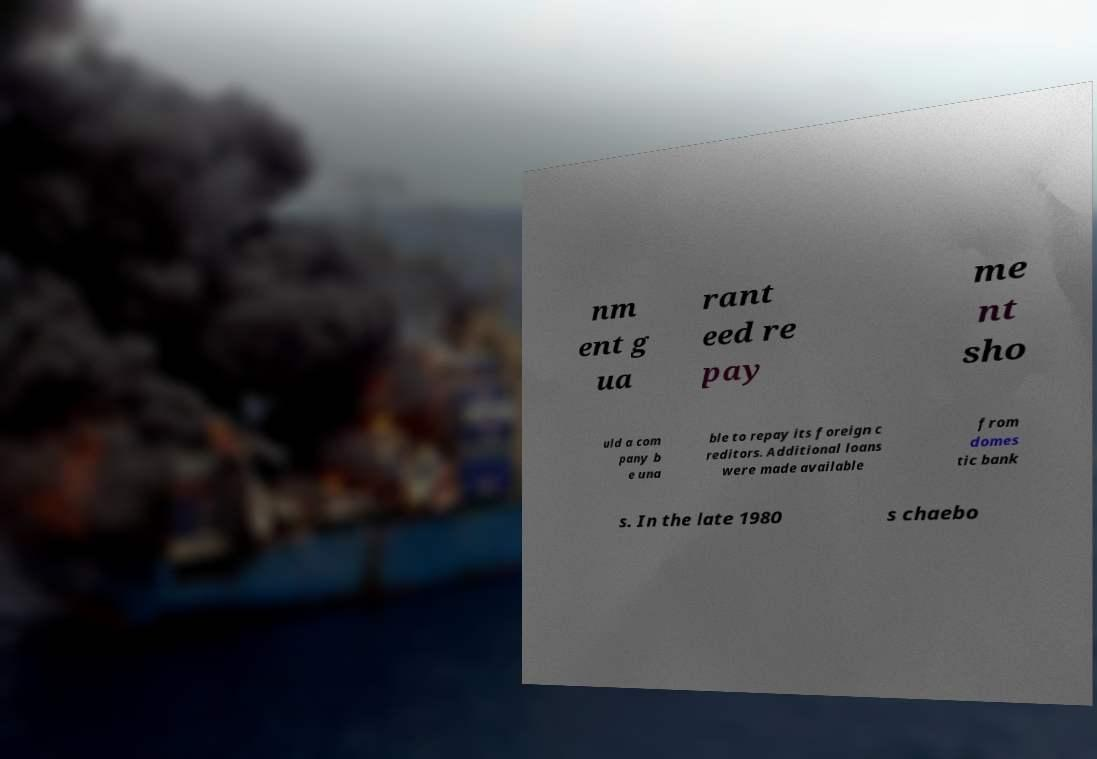Could you assist in decoding the text presented in this image and type it out clearly? nm ent g ua rant eed re pay me nt sho uld a com pany b e una ble to repay its foreign c reditors. Additional loans were made available from domes tic bank s. In the late 1980 s chaebo 